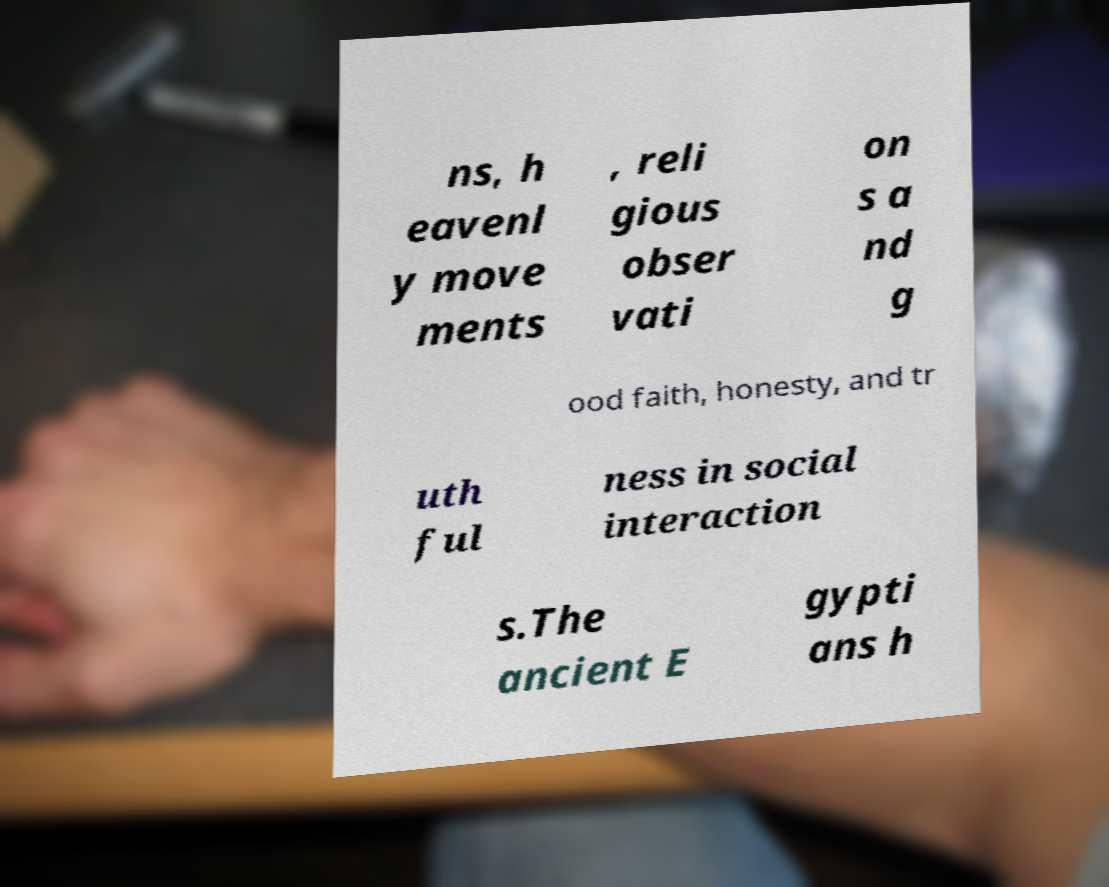Please identify and transcribe the text found in this image. ns, h eavenl y move ments , reli gious obser vati on s a nd g ood faith, honesty, and tr uth ful ness in social interaction s.The ancient E gypti ans h 